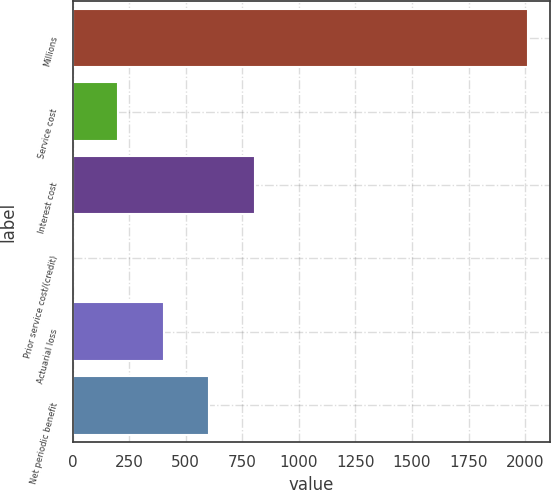<chart> <loc_0><loc_0><loc_500><loc_500><bar_chart><fcel>Millions<fcel>Service cost<fcel>Interest cost<fcel>Prior service cost/(credit)<fcel>Actuarial loss<fcel>Net periodic benefit<nl><fcel>2011<fcel>202.9<fcel>805.6<fcel>2<fcel>403.8<fcel>604.7<nl></chart> 